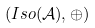<formula> <loc_0><loc_0><loc_500><loc_500>( I s o ( { \mathcal { A } } ) , \oplus )</formula> 